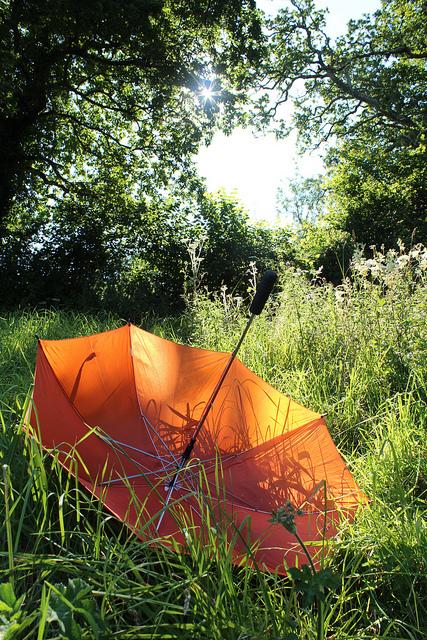Where is the umbrella used for?
Quick response, please. Sun. What is this device used for?
Concise answer only. Rain. What color is the umbrella?
Quick response, please. Orange. 